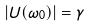<formula> <loc_0><loc_0><loc_500><loc_500>| U ( \omega _ { 0 } ) | = \gamma</formula> 